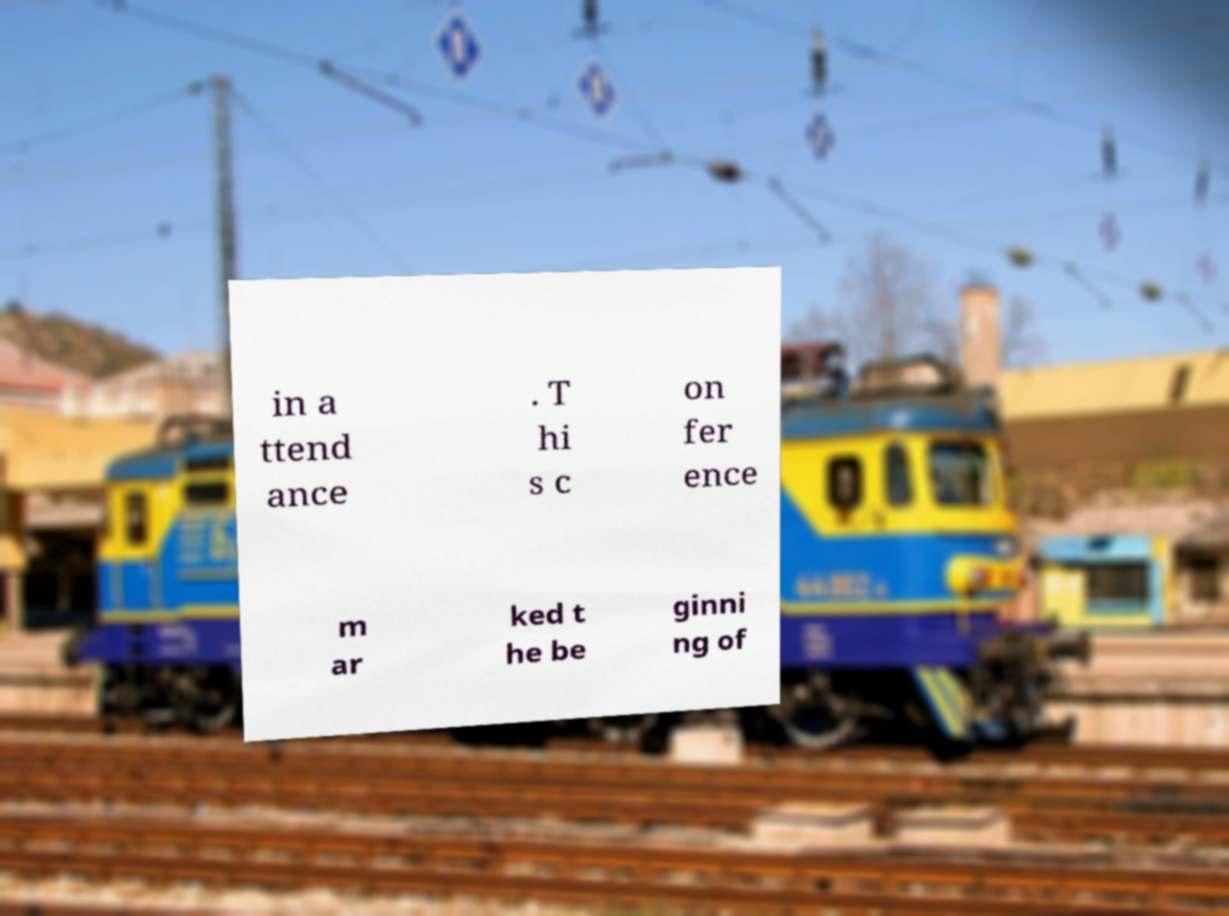Could you extract and type out the text from this image? in a ttend ance . T hi s c on fer ence m ar ked t he be ginni ng of 